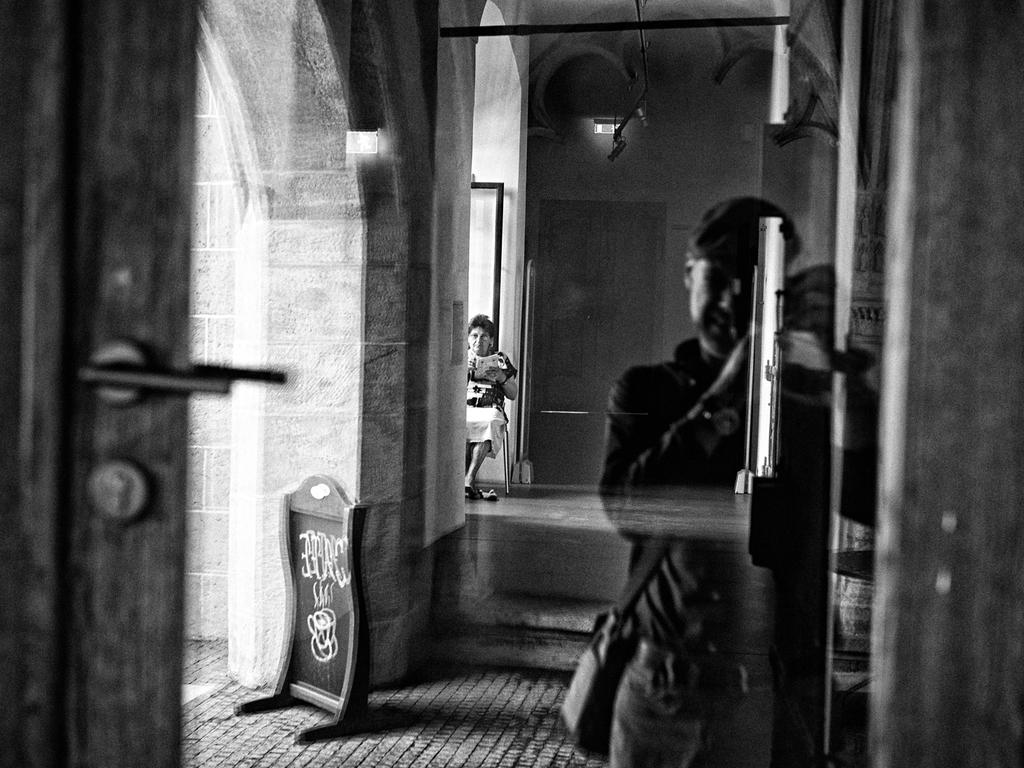What is the woman doing in the image? The woman is sitting on a chair in the image. What is the woman holding in the image? The woman is holding an object in the image. What can be seen in the background of the image? There are lights visible in the image. What is present on the wall in the image? There is a board in the image. What is the door in the image like? There is a door with a handle in the image. What is the man wearing in the image? A man is wearing a bag in the image. What type of jeans is the sack wearing in the image? There is no sack or jeans present in the image. How does the man start the engine in the image? There is no engine or indication of starting one in the image. 